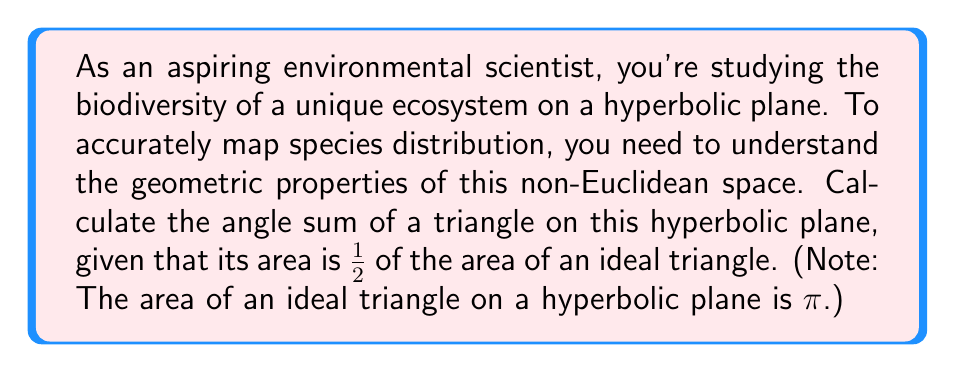Can you solve this math problem? Let's approach this step-by-step:

1) In hyperbolic geometry, the angle sum of a triangle is always less than $\pi$ radians (or 180°).

2) The relationship between the area of a triangle and its angle sum in hyperbolic geometry is given by the Gauss-Bonnet formula:

   $$A = \pi - (\alpha + \beta + \gamma)$$

   where $A$ is the area of the triangle, and $\alpha$, $\beta$, and $\gamma$ are the angles of the triangle.

3) We're given that the area of our triangle is $\frac{1}{2}$ of an ideal triangle's area. The area of an ideal triangle is $\pi$, so:

   $$A = \frac{1}{2} \pi$$

4) Substituting this into the Gauss-Bonnet formula:

   $$\frac{1}{2} \pi = \pi - (\alpha + \beta + \gamma)$$

5) Solving for the angle sum:

   $$\alpha + \beta + \gamma = \pi - \frac{1}{2} \pi = \frac{1}{2} \pi$$

6) Converting to degrees:

   $$\frac{1}{2} \pi \text{ radians} = 90°$$

Thus, the angle sum of this triangle on the hyperbolic plane is $\frac{1}{2} \pi$ radians or 90°.
Answer: $\frac{1}{2} \pi$ radians or 90° 